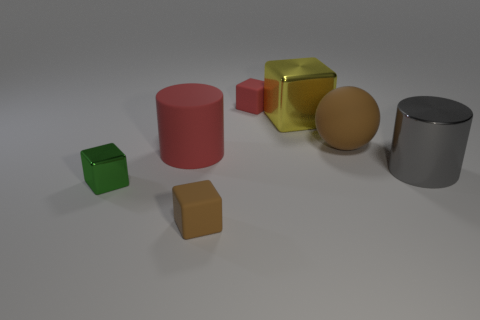Subtract all cyan balls. Subtract all green cubes. How many balls are left? 1 Add 1 brown rubber blocks. How many objects exist? 8 Subtract all cylinders. How many objects are left? 5 Subtract all cyan matte cylinders. Subtract all red matte blocks. How many objects are left? 6 Add 4 red rubber things. How many red rubber things are left? 6 Add 7 small red rubber blocks. How many small red rubber blocks exist? 8 Subtract 1 gray cylinders. How many objects are left? 6 